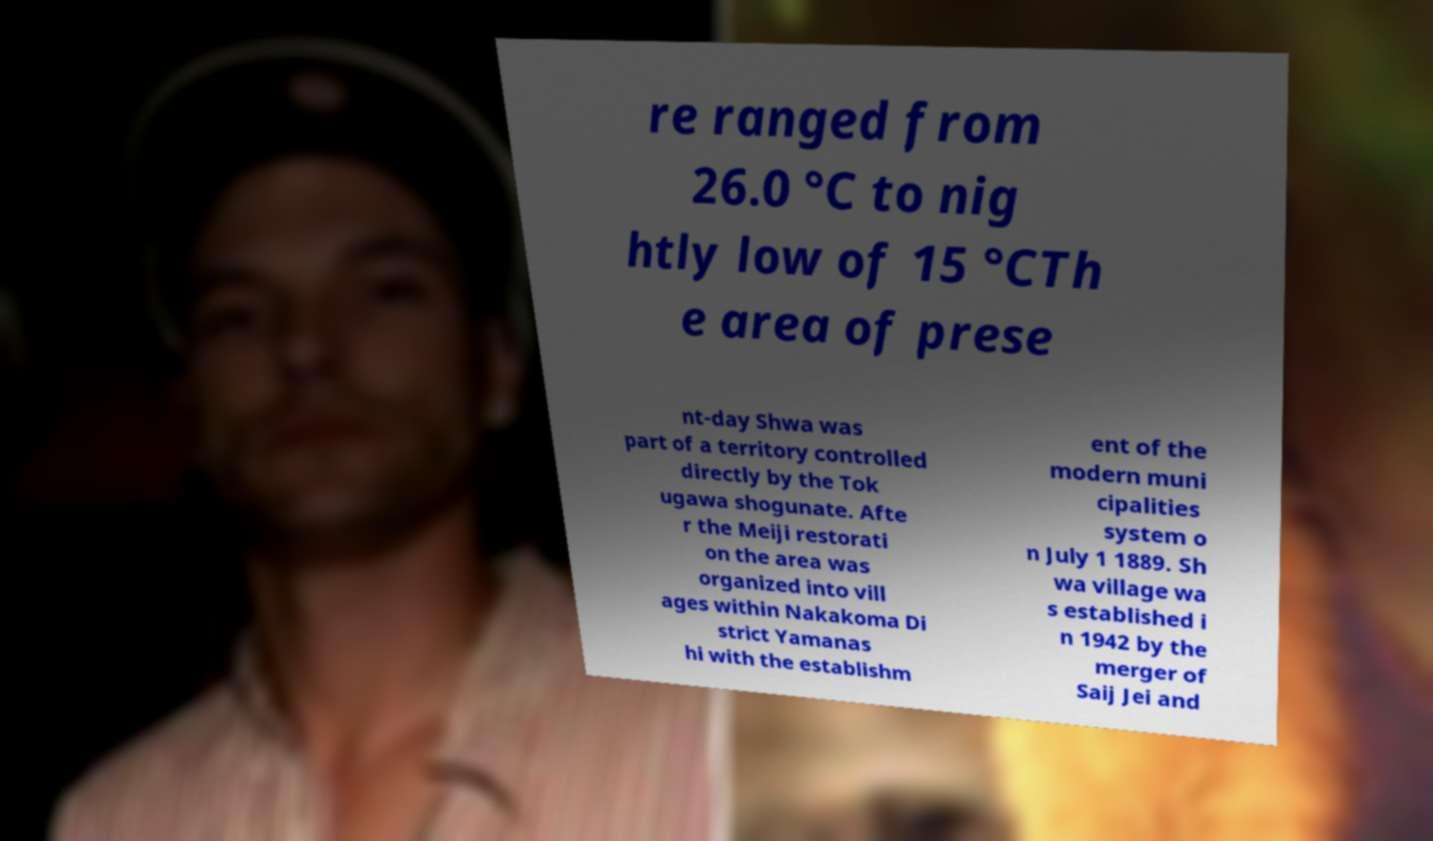What messages or text are displayed in this image? I need them in a readable, typed format. re ranged from 26.0 °C to nig htly low of 15 °CTh e area of prese nt-day Shwa was part of a territory controlled directly by the Tok ugawa shogunate. Afte r the Meiji restorati on the area was organized into vill ages within Nakakoma Di strict Yamanas hi with the establishm ent of the modern muni cipalities system o n July 1 1889. Sh wa village wa s established i n 1942 by the merger of Saij Jei and 